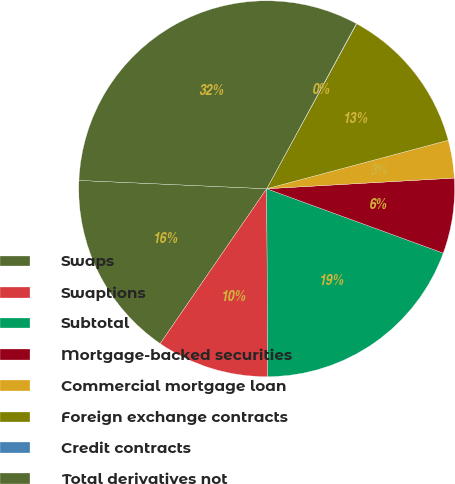Convert chart. <chart><loc_0><loc_0><loc_500><loc_500><pie_chart><fcel>Swaps<fcel>Swaptions<fcel>Subtotal<fcel>Mortgage-backed securities<fcel>Commercial mortgage loan<fcel>Foreign exchange contracts<fcel>Credit contracts<fcel>Total derivatives not<nl><fcel>16.12%<fcel>9.68%<fcel>19.34%<fcel>6.47%<fcel>3.25%<fcel>12.9%<fcel>0.03%<fcel>32.21%<nl></chart> 